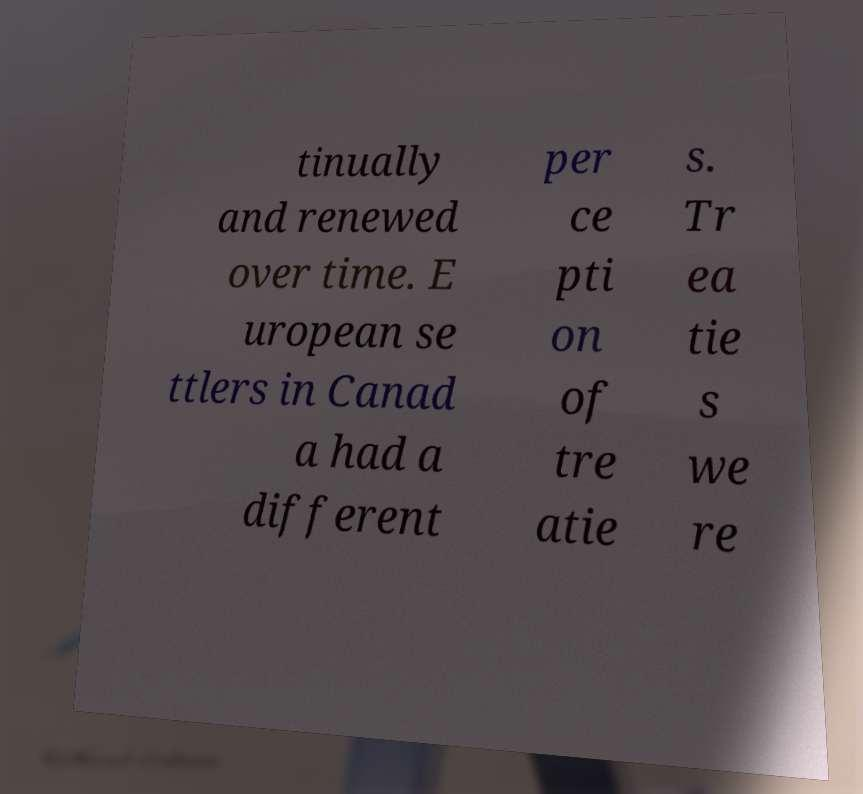Please identify and transcribe the text found in this image. tinually and renewed over time. E uropean se ttlers in Canad a had a different per ce pti on of tre atie s. Tr ea tie s we re 